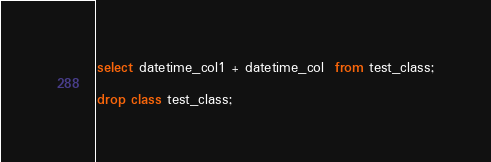<code> <loc_0><loc_0><loc_500><loc_500><_SQL_>select datetime_col1 + datetime_col  from test_class;

drop class test_class;</code> 